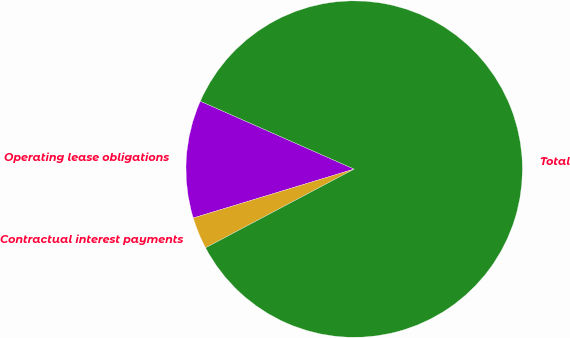<chart> <loc_0><loc_0><loc_500><loc_500><pie_chart><fcel>Operating lease obligations<fcel>Contractual interest payments<fcel>Total<nl><fcel>11.31%<fcel>3.06%<fcel>85.63%<nl></chart> 